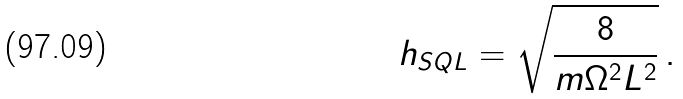<formula> <loc_0><loc_0><loc_500><loc_500>h _ { S Q L } = \sqrt { \frac { 8 } { m \Omega ^ { 2 } L ^ { 2 } } } \, .</formula> 